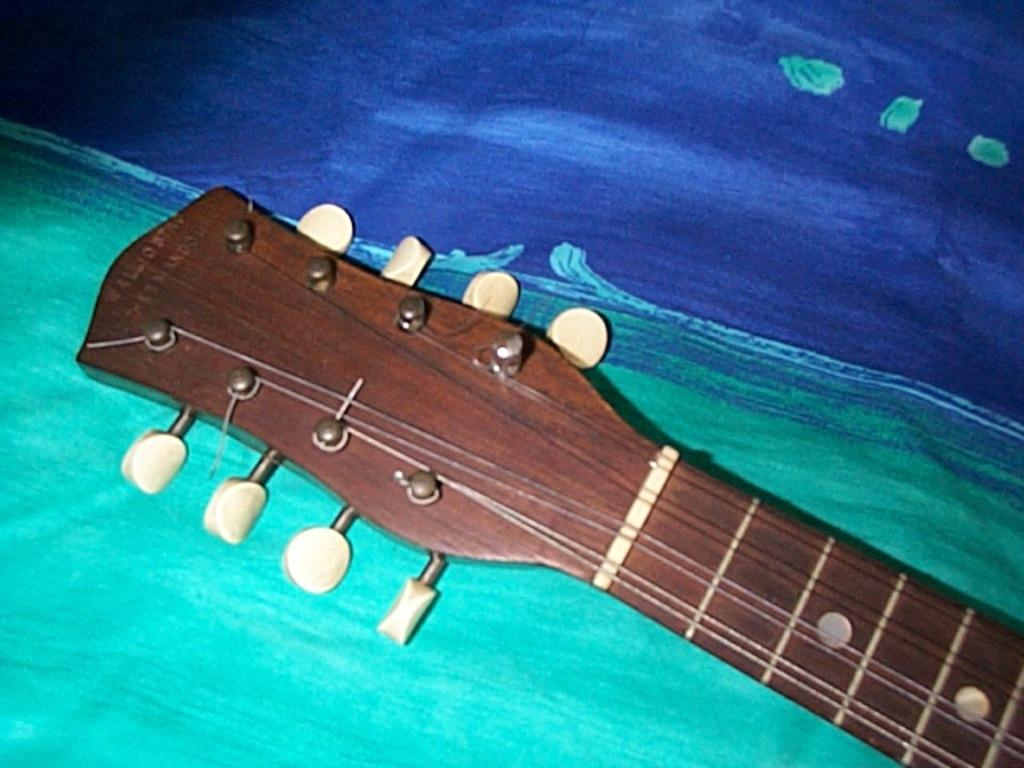What musical instrument is present in the image? There is a guitar in the image. How much of the guitar is visible in the image? The guitar is half visible in the image. On what surface is the guitar placed? The guitar is placed on a cloth. What colors can be seen on the cloth? The cloth has green and blue colors. What type of baseball is visible on the guitar in the image? There is no baseball present in the image; it features a guitar placed on a cloth with green and blue colors. 